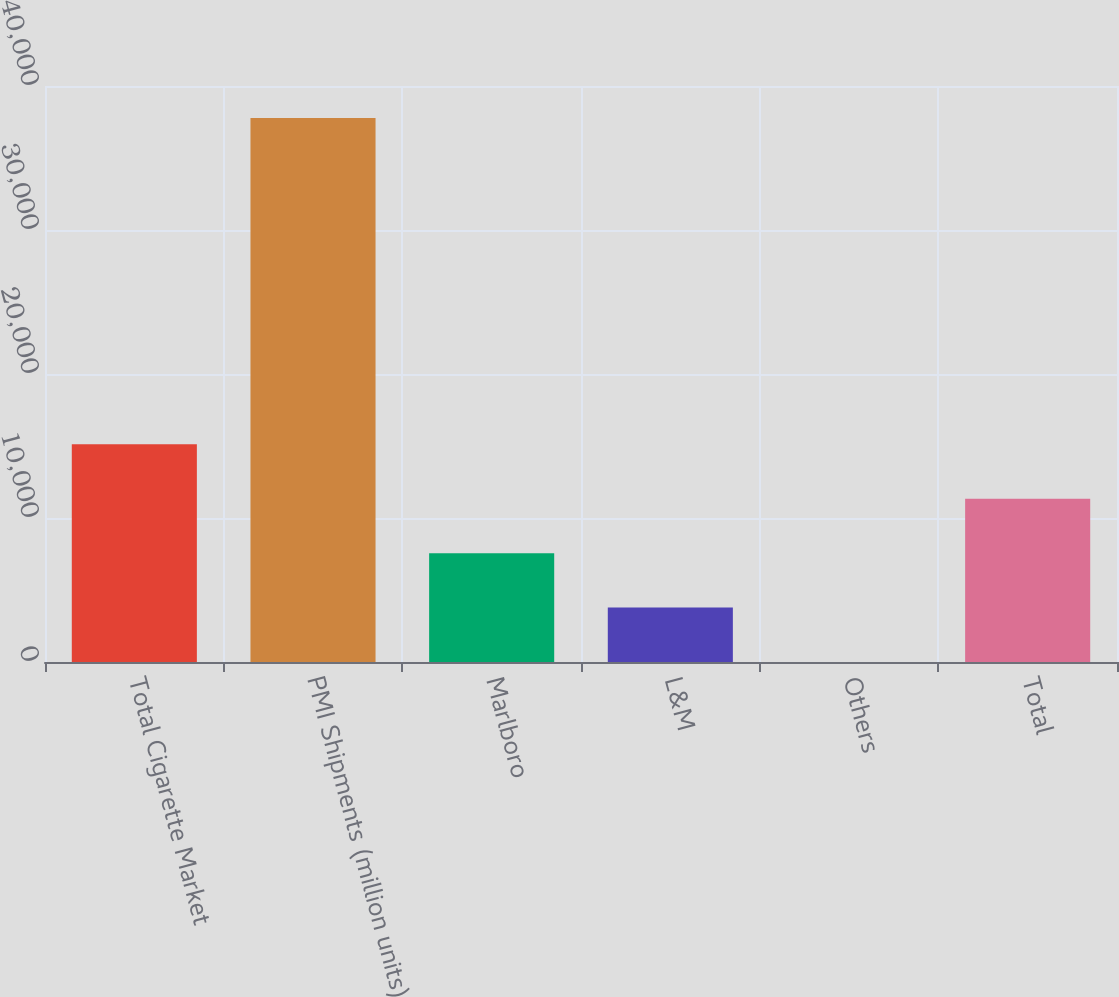Convert chart to OTSL. <chart><loc_0><loc_0><loc_500><loc_500><bar_chart><fcel>Total Cigarette Market<fcel>PMI Shipments (million units)<fcel>Marlboro<fcel>L&M<fcel>Others<fcel>Total<nl><fcel>15113.9<fcel>37782<fcel>7557.92<fcel>3779.91<fcel>1.9<fcel>11335.9<nl></chart> 